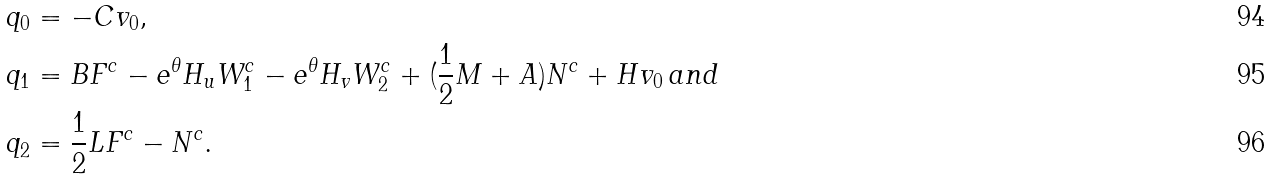<formula> <loc_0><loc_0><loc_500><loc_500>& q _ { 0 } = - C v _ { 0 } , \\ & q _ { 1 } = B F ^ { c } - e ^ { \theta } H _ { u } W _ { 1 } ^ { c } - e ^ { \theta } H _ { v } W _ { 2 } ^ { c } + ( \frac { 1 } { 2 } M + A ) N ^ { c } + H v _ { 0 } \, a n d \\ & q _ { 2 } = \frac { 1 } { 2 } L F ^ { c } - N ^ { c } .</formula> 